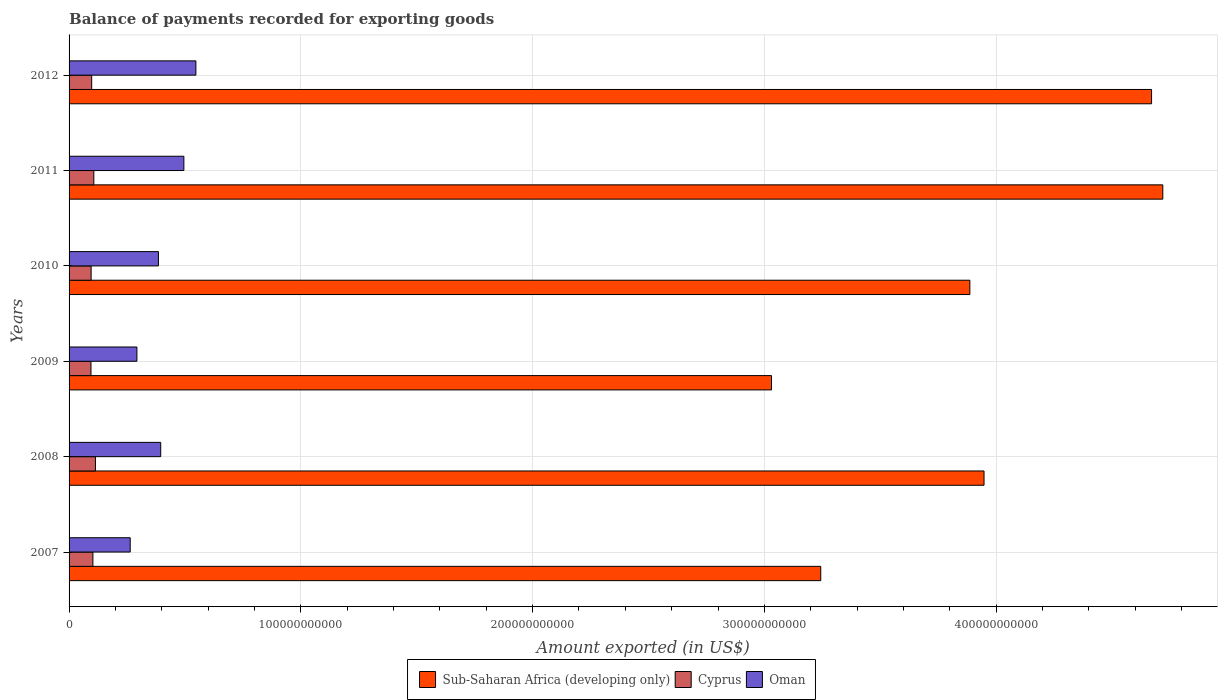How many different coloured bars are there?
Make the answer very short. 3. Are the number of bars per tick equal to the number of legend labels?
Your answer should be compact. Yes. Are the number of bars on each tick of the Y-axis equal?
Your answer should be very brief. Yes. How many bars are there on the 3rd tick from the top?
Make the answer very short. 3. What is the label of the 1st group of bars from the top?
Make the answer very short. 2012. What is the amount exported in Cyprus in 2010?
Your answer should be compact. 9.52e+09. Across all years, what is the maximum amount exported in Oman?
Ensure brevity in your answer.  5.47e+1. Across all years, what is the minimum amount exported in Sub-Saharan Africa (developing only)?
Make the answer very short. 3.03e+11. What is the total amount exported in Oman in the graph?
Your response must be concise. 2.38e+11. What is the difference between the amount exported in Sub-Saharan Africa (developing only) in 2007 and that in 2011?
Ensure brevity in your answer.  -1.48e+11. What is the difference between the amount exported in Sub-Saharan Africa (developing only) in 2011 and the amount exported in Oman in 2012?
Provide a short and direct response. 4.17e+11. What is the average amount exported in Cyprus per year?
Provide a short and direct response. 1.02e+1. In the year 2011, what is the difference between the amount exported in Cyprus and amount exported in Sub-Saharan Africa (developing only)?
Keep it short and to the point. -4.61e+11. In how many years, is the amount exported in Sub-Saharan Africa (developing only) greater than 40000000000 US$?
Your answer should be very brief. 6. What is the ratio of the amount exported in Sub-Saharan Africa (developing only) in 2008 to that in 2009?
Your answer should be compact. 1.3. Is the amount exported in Sub-Saharan Africa (developing only) in 2008 less than that in 2011?
Your answer should be compact. Yes. Is the difference between the amount exported in Cyprus in 2007 and 2011 greater than the difference between the amount exported in Sub-Saharan Africa (developing only) in 2007 and 2011?
Provide a succinct answer. Yes. What is the difference between the highest and the second highest amount exported in Sub-Saharan Africa (developing only)?
Ensure brevity in your answer.  4.85e+09. What is the difference between the highest and the lowest amount exported in Oman?
Give a very brief answer. 2.83e+1. In how many years, is the amount exported in Sub-Saharan Africa (developing only) greater than the average amount exported in Sub-Saharan Africa (developing only) taken over all years?
Provide a short and direct response. 3. Is the sum of the amount exported in Oman in 2008 and 2010 greater than the maximum amount exported in Sub-Saharan Africa (developing only) across all years?
Offer a terse response. No. What does the 2nd bar from the top in 2012 represents?
Your answer should be compact. Cyprus. What does the 3rd bar from the bottom in 2012 represents?
Your answer should be compact. Oman. Is it the case that in every year, the sum of the amount exported in Oman and amount exported in Sub-Saharan Africa (developing only) is greater than the amount exported in Cyprus?
Keep it short and to the point. Yes. How many bars are there?
Your response must be concise. 18. Are all the bars in the graph horizontal?
Make the answer very short. Yes. How many years are there in the graph?
Keep it short and to the point. 6. What is the difference between two consecutive major ticks on the X-axis?
Offer a terse response. 1.00e+11. Does the graph contain grids?
Make the answer very short. Yes. How are the legend labels stacked?
Make the answer very short. Horizontal. What is the title of the graph?
Ensure brevity in your answer.  Balance of payments recorded for exporting goods. What is the label or title of the X-axis?
Your answer should be compact. Amount exported (in US$). What is the Amount exported (in US$) of Sub-Saharan Africa (developing only) in 2007?
Ensure brevity in your answer.  3.24e+11. What is the Amount exported (in US$) of Cyprus in 2007?
Ensure brevity in your answer.  1.03e+1. What is the Amount exported (in US$) in Oman in 2007?
Give a very brief answer. 2.64e+1. What is the Amount exported (in US$) of Sub-Saharan Africa (developing only) in 2008?
Provide a short and direct response. 3.95e+11. What is the Amount exported (in US$) of Cyprus in 2008?
Your answer should be very brief. 1.14e+1. What is the Amount exported (in US$) of Oman in 2008?
Offer a very short reply. 3.95e+1. What is the Amount exported (in US$) of Sub-Saharan Africa (developing only) in 2009?
Keep it short and to the point. 3.03e+11. What is the Amount exported (in US$) of Cyprus in 2009?
Offer a very short reply. 9.46e+09. What is the Amount exported (in US$) in Oman in 2009?
Your answer should be very brief. 2.93e+1. What is the Amount exported (in US$) in Sub-Saharan Africa (developing only) in 2010?
Your answer should be compact. 3.89e+11. What is the Amount exported (in US$) in Cyprus in 2010?
Provide a short and direct response. 9.52e+09. What is the Amount exported (in US$) of Oman in 2010?
Your response must be concise. 3.86e+1. What is the Amount exported (in US$) of Sub-Saharan Africa (developing only) in 2011?
Your response must be concise. 4.72e+11. What is the Amount exported (in US$) of Cyprus in 2011?
Ensure brevity in your answer.  1.07e+1. What is the Amount exported (in US$) of Oman in 2011?
Your response must be concise. 4.95e+1. What is the Amount exported (in US$) in Sub-Saharan Africa (developing only) in 2012?
Your answer should be very brief. 4.67e+11. What is the Amount exported (in US$) in Cyprus in 2012?
Provide a succinct answer. 9.76e+09. What is the Amount exported (in US$) of Oman in 2012?
Ensure brevity in your answer.  5.47e+1. Across all years, what is the maximum Amount exported (in US$) of Sub-Saharan Africa (developing only)?
Offer a very short reply. 4.72e+11. Across all years, what is the maximum Amount exported (in US$) in Cyprus?
Offer a very short reply. 1.14e+1. Across all years, what is the maximum Amount exported (in US$) of Oman?
Offer a very short reply. 5.47e+1. Across all years, what is the minimum Amount exported (in US$) of Sub-Saharan Africa (developing only)?
Ensure brevity in your answer.  3.03e+11. Across all years, what is the minimum Amount exported (in US$) in Cyprus?
Offer a very short reply. 9.46e+09. Across all years, what is the minimum Amount exported (in US$) in Oman?
Give a very brief answer. 2.64e+1. What is the total Amount exported (in US$) in Sub-Saharan Africa (developing only) in the graph?
Provide a short and direct response. 2.35e+12. What is the total Amount exported (in US$) in Cyprus in the graph?
Make the answer very short. 6.11e+1. What is the total Amount exported (in US$) in Oman in the graph?
Offer a terse response. 2.38e+11. What is the difference between the Amount exported (in US$) in Sub-Saharan Africa (developing only) in 2007 and that in 2008?
Provide a short and direct response. -7.05e+1. What is the difference between the Amount exported (in US$) in Cyprus in 2007 and that in 2008?
Make the answer very short. -1.09e+09. What is the difference between the Amount exported (in US$) in Oman in 2007 and that in 2008?
Ensure brevity in your answer.  -1.32e+1. What is the difference between the Amount exported (in US$) in Sub-Saharan Africa (developing only) in 2007 and that in 2009?
Provide a short and direct response. 2.13e+1. What is the difference between the Amount exported (in US$) in Cyprus in 2007 and that in 2009?
Keep it short and to the point. 8.28e+08. What is the difference between the Amount exported (in US$) of Oman in 2007 and that in 2009?
Provide a succinct answer. -2.90e+09. What is the difference between the Amount exported (in US$) of Sub-Saharan Africa (developing only) in 2007 and that in 2010?
Provide a succinct answer. -6.43e+1. What is the difference between the Amount exported (in US$) of Cyprus in 2007 and that in 2010?
Provide a succinct answer. 7.69e+08. What is the difference between the Amount exported (in US$) of Oman in 2007 and that in 2010?
Give a very brief answer. -1.22e+1. What is the difference between the Amount exported (in US$) in Sub-Saharan Africa (developing only) in 2007 and that in 2011?
Offer a terse response. -1.48e+11. What is the difference between the Amount exported (in US$) in Cyprus in 2007 and that in 2011?
Give a very brief answer. -3.96e+08. What is the difference between the Amount exported (in US$) of Oman in 2007 and that in 2011?
Your response must be concise. -2.32e+1. What is the difference between the Amount exported (in US$) of Sub-Saharan Africa (developing only) in 2007 and that in 2012?
Your response must be concise. -1.43e+11. What is the difference between the Amount exported (in US$) of Cyprus in 2007 and that in 2012?
Ensure brevity in your answer.  5.29e+08. What is the difference between the Amount exported (in US$) of Oman in 2007 and that in 2012?
Your answer should be compact. -2.83e+1. What is the difference between the Amount exported (in US$) of Sub-Saharan Africa (developing only) in 2008 and that in 2009?
Give a very brief answer. 9.17e+1. What is the difference between the Amount exported (in US$) of Cyprus in 2008 and that in 2009?
Offer a very short reply. 1.92e+09. What is the difference between the Amount exported (in US$) of Oman in 2008 and that in 2009?
Your response must be concise. 1.03e+1. What is the difference between the Amount exported (in US$) in Sub-Saharan Africa (developing only) in 2008 and that in 2010?
Ensure brevity in your answer.  6.12e+09. What is the difference between the Amount exported (in US$) of Cyprus in 2008 and that in 2010?
Your response must be concise. 1.86e+09. What is the difference between the Amount exported (in US$) in Oman in 2008 and that in 2010?
Your answer should be very brief. 9.86e+08. What is the difference between the Amount exported (in US$) of Sub-Saharan Africa (developing only) in 2008 and that in 2011?
Provide a short and direct response. -7.71e+1. What is the difference between the Amount exported (in US$) in Cyprus in 2008 and that in 2011?
Your answer should be compact. 6.98e+08. What is the difference between the Amount exported (in US$) of Oman in 2008 and that in 2011?
Make the answer very short. -9.99e+09. What is the difference between the Amount exported (in US$) in Sub-Saharan Africa (developing only) in 2008 and that in 2012?
Offer a terse response. -7.23e+1. What is the difference between the Amount exported (in US$) of Cyprus in 2008 and that in 2012?
Offer a very short reply. 1.62e+09. What is the difference between the Amount exported (in US$) of Oman in 2008 and that in 2012?
Ensure brevity in your answer.  -1.52e+1. What is the difference between the Amount exported (in US$) in Sub-Saharan Africa (developing only) in 2009 and that in 2010?
Give a very brief answer. -8.56e+1. What is the difference between the Amount exported (in US$) of Cyprus in 2009 and that in 2010?
Give a very brief answer. -5.90e+07. What is the difference between the Amount exported (in US$) of Oman in 2009 and that in 2010?
Ensure brevity in your answer.  -9.29e+09. What is the difference between the Amount exported (in US$) in Sub-Saharan Africa (developing only) in 2009 and that in 2011?
Make the answer very short. -1.69e+11. What is the difference between the Amount exported (in US$) of Cyprus in 2009 and that in 2011?
Provide a short and direct response. -1.22e+09. What is the difference between the Amount exported (in US$) in Oman in 2009 and that in 2011?
Your answer should be very brief. -2.03e+1. What is the difference between the Amount exported (in US$) in Sub-Saharan Africa (developing only) in 2009 and that in 2012?
Provide a succinct answer. -1.64e+11. What is the difference between the Amount exported (in US$) of Cyprus in 2009 and that in 2012?
Ensure brevity in your answer.  -2.98e+08. What is the difference between the Amount exported (in US$) in Oman in 2009 and that in 2012?
Your answer should be compact. -2.55e+1. What is the difference between the Amount exported (in US$) in Sub-Saharan Africa (developing only) in 2010 and that in 2011?
Provide a short and direct response. -8.33e+1. What is the difference between the Amount exported (in US$) of Cyprus in 2010 and that in 2011?
Provide a short and direct response. -1.16e+09. What is the difference between the Amount exported (in US$) of Oman in 2010 and that in 2011?
Your response must be concise. -1.10e+1. What is the difference between the Amount exported (in US$) of Sub-Saharan Africa (developing only) in 2010 and that in 2012?
Make the answer very short. -7.84e+1. What is the difference between the Amount exported (in US$) in Cyprus in 2010 and that in 2012?
Your answer should be compact. -2.39e+08. What is the difference between the Amount exported (in US$) of Oman in 2010 and that in 2012?
Give a very brief answer. -1.62e+1. What is the difference between the Amount exported (in US$) in Sub-Saharan Africa (developing only) in 2011 and that in 2012?
Your answer should be very brief. 4.85e+09. What is the difference between the Amount exported (in US$) in Cyprus in 2011 and that in 2012?
Provide a short and direct response. 9.25e+08. What is the difference between the Amount exported (in US$) in Oman in 2011 and that in 2012?
Offer a terse response. -5.19e+09. What is the difference between the Amount exported (in US$) in Sub-Saharan Africa (developing only) in 2007 and the Amount exported (in US$) in Cyprus in 2008?
Provide a short and direct response. 3.13e+11. What is the difference between the Amount exported (in US$) in Sub-Saharan Africa (developing only) in 2007 and the Amount exported (in US$) in Oman in 2008?
Give a very brief answer. 2.85e+11. What is the difference between the Amount exported (in US$) of Cyprus in 2007 and the Amount exported (in US$) of Oman in 2008?
Ensure brevity in your answer.  -2.93e+1. What is the difference between the Amount exported (in US$) of Sub-Saharan Africa (developing only) in 2007 and the Amount exported (in US$) of Cyprus in 2009?
Provide a short and direct response. 3.15e+11. What is the difference between the Amount exported (in US$) of Sub-Saharan Africa (developing only) in 2007 and the Amount exported (in US$) of Oman in 2009?
Your answer should be compact. 2.95e+11. What is the difference between the Amount exported (in US$) in Cyprus in 2007 and the Amount exported (in US$) in Oman in 2009?
Your answer should be compact. -1.90e+1. What is the difference between the Amount exported (in US$) in Sub-Saharan Africa (developing only) in 2007 and the Amount exported (in US$) in Cyprus in 2010?
Your answer should be compact. 3.15e+11. What is the difference between the Amount exported (in US$) in Sub-Saharan Africa (developing only) in 2007 and the Amount exported (in US$) in Oman in 2010?
Your answer should be very brief. 2.86e+11. What is the difference between the Amount exported (in US$) in Cyprus in 2007 and the Amount exported (in US$) in Oman in 2010?
Your response must be concise. -2.83e+1. What is the difference between the Amount exported (in US$) of Sub-Saharan Africa (developing only) in 2007 and the Amount exported (in US$) of Cyprus in 2011?
Offer a very short reply. 3.14e+11. What is the difference between the Amount exported (in US$) of Sub-Saharan Africa (developing only) in 2007 and the Amount exported (in US$) of Oman in 2011?
Provide a succinct answer. 2.75e+11. What is the difference between the Amount exported (in US$) in Cyprus in 2007 and the Amount exported (in US$) in Oman in 2011?
Your answer should be very brief. -3.92e+1. What is the difference between the Amount exported (in US$) in Sub-Saharan Africa (developing only) in 2007 and the Amount exported (in US$) in Cyprus in 2012?
Provide a succinct answer. 3.15e+11. What is the difference between the Amount exported (in US$) of Sub-Saharan Africa (developing only) in 2007 and the Amount exported (in US$) of Oman in 2012?
Your response must be concise. 2.70e+11. What is the difference between the Amount exported (in US$) in Cyprus in 2007 and the Amount exported (in US$) in Oman in 2012?
Provide a succinct answer. -4.44e+1. What is the difference between the Amount exported (in US$) of Sub-Saharan Africa (developing only) in 2008 and the Amount exported (in US$) of Cyprus in 2009?
Keep it short and to the point. 3.85e+11. What is the difference between the Amount exported (in US$) of Sub-Saharan Africa (developing only) in 2008 and the Amount exported (in US$) of Oman in 2009?
Give a very brief answer. 3.66e+11. What is the difference between the Amount exported (in US$) in Cyprus in 2008 and the Amount exported (in US$) in Oman in 2009?
Your response must be concise. -1.79e+1. What is the difference between the Amount exported (in US$) in Sub-Saharan Africa (developing only) in 2008 and the Amount exported (in US$) in Cyprus in 2010?
Offer a terse response. 3.85e+11. What is the difference between the Amount exported (in US$) in Sub-Saharan Africa (developing only) in 2008 and the Amount exported (in US$) in Oman in 2010?
Your response must be concise. 3.56e+11. What is the difference between the Amount exported (in US$) in Cyprus in 2008 and the Amount exported (in US$) in Oman in 2010?
Your answer should be very brief. -2.72e+1. What is the difference between the Amount exported (in US$) of Sub-Saharan Africa (developing only) in 2008 and the Amount exported (in US$) of Cyprus in 2011?
Your answer should be compact. 3.84e+11. What is the difference between the Amount exported (in US$) of Sub-Saharan Africa (developing only) in 2008 and the Amount exported (in US$) of Oman in 2011?
Give a very brief answer. 3.45e+11. What is the difference between the Amount exported (in US$) in Cyprus in 2008 and the Amount exported (in US$) in Oman in 2011?
Your answer should be compact. -3.82e+1. What is the difference between the Amount exported (in US$) in Sub-Saharan Africa (developing only) in 2008 and the Amount exported (in US$) in Cyprus in 2012?
Make the answer very short. 3.85e+11. What is the difference between the Amount exported (in US$) in Sub-Saharan Africa (developing only) in 2008 and the Amount exported (in US$) in Oman in 2012?
Keep it short and to the point. 3.40e+11. What is the difference between the Amount exported (in US$) of Cyprus in 2008 and the Amount exported (in US$) of Oman in 2012?
Provide a short and direct response. -4.33e+1. What is the difference between the Amount exported (in US$) of Sub-Saharan Africa (developing only) in 2009 and the Amount exported (in US$) of Cyprus in 2010?
Make the answer very short. 2.94e+11. What is the difference between the Amount exported (in US$) in Sub-Saharan Africa (developing only) in 2009 and the Amount exported (in US$) in Oman in 2010?
Your response must be concise. 2.65e+11. What is the difference between the Amount exported (in US$) of Cyprus in 2009 and the Amount exported (in US$) of Oman in 2010?
Provide a succinct answer. -2.91e+1. What is the difference between the Amount exported (in US$) of Sub-Saharan Africa (developing only) in 2009 and the Amount exported (in US$) of Cyprus in 2011?
Your answer should be compact. 2.92e+11. What is the difference between the Amount exported (in US$) of Sub-Saharan Africa (developing only) in 2009 and the Amount exported (in US$) of Oman in 2011?
Offer a very short reply. 2.54e+11. What is the difference between the Amount exported (in US$) of Cyprus in 2009 and the Amount exported (in US$) of Oman in 2011?
Your answer should be very brief. -4.01e+1. What is the difference between the Amount exported (in US$) of Sub-Saharan Africa (developing only) in 2009 and the Amount exported (in US$) of Cyprus in 2012?
Give a very brief answer. 2.93e+11. What is the difference between the Amount exported (in US$) in Sub-Saharan Africa (developing only) in 2009 and the Amount exported (in US$) in Oman in 2012?
Keep it short and to the point. 2.48e+11. What is the difference between the Amount exported (in US$) of Cyprus in 2009 and the Amount exported (in US$) of Oman in 2012?
Your response must be concise. -4.53e+1. What is the difference between the Amount exported (in US$) in Sub-Saharan Africa (developing only) in 2010 and the Amount exported (in US$) in Cyprus in 2011?
Offer a very short reply. 3.78e+11. What is the difference between the Amount exported (in US$) of Sub-Saharan Africa (developing only) in 2010 and the Amount exported (in US$) of Oman in 2011?
Your response must be concise. 3.39e+11. What is the difference between the Amount exported (in US$) in Cyprus in 2010 and the Amount exported (in US$) in Oman in 2011?
Offer a very short reply. -4.00e+1. What is the difference between the Amount exported (in US$) in Sub-Saharan Africa (developing only) in 2010 and the Amount exported (in US$) in Cyprus in 2012?
Make the answer very short. 3.79e+11. What is the difference between the Amount exported (in US$) in Sub-Saharan Africa (developing only) in 2010 and the Amount exported (in US$) in Oman in 2012?
Make the answer very short. 3.34e+11. What is the difference between the Amount exported (in US$) in Cyprus in 2010 and the Amount exported (in US$) in Oman in 2012?
Offer a very short reply. -4.52e+1. What is the difference between the Amount exported (in US$) of Sub-Saharan Africa (developing only) in 2011 and the Amount exported (in US$) of Cyprus in 2012?
Provide a short and direct response. 4.62e+11. What is the difference between the Amount exported (in US$) of Sub-Saharan Africa (developing only) in 2011 and the Amount exported (in US$) of Oman in 2012?
Provide a short and direct response. 4.17e+11. What is the difference between the Amount exported (in US$) of Cyprus in 2011 and the Amount exported (in US$) of Oman in 2012?
Offer a very short reply. -4.40e+1. What is the average Amount exported (in US$) of Sub-Saharan Africa (developing only) per year?
Your answer should be compact. 3.92e+11. What is the average Amount exported (in US$) in Cyprus per year?
Your answer should be compact. 1.02e+1. What is the average Amount exported (in US$) of Oman per year?
Give a very brief answer. 3.97e+1. In the year 2007, what is the difference between the Amount exported (in US$) of Sub-Saharan Africa (developing only) and Amount exported (in US$) of Cyprus?
Provide a succinct answer. 3.14e+11. In the year 2007, what is the difference between the Amount exported (in US$) in Sub-Saharan Africa (developing only) and Amount exported (in US$) in Oman?
Make the answer very short. 2.98e+11. In the year 2007, what is the difference between the Amount exported (in US$) in Cyprus and Amount exported (in US$) in Oman?
Your answer should be very brief. -1.61e+1. In the year 2008, what is the difference between the Amount exported (in US$) of Sub-Saharan Africa (developing only) and Amount exported (in US$) of Cyprus?
Give a very brief answer. 3.83e+11. In the year 2008, what is the difference between the Amount exported (in US$) of Sub-Saharan Africa (developing only) and Amount exported (in US$) of Oman?
Your answer should be very brief. 3.55e+11. In the year 2008, what is the difference between the Amount exported (in US$) in Cyprus and Amount exported (in US$) in Oman?
Offer a terse response. -2.82e+1. In the year 2009, what is the difference between the Amount exported (in US$) in Sub-Saharan Africa (developing only) and Amount exported (in US$) in Cyprus?
Ensure brevity in your answer.  2.94e+11. In the year 2009, what is the difference between the Amount exported (in US$) in Sub-Saharan Africa (developing only) and Amount exported (in US$) in Oman?
Give a very brief answer. 2.74e+11. In the year 2009, what is the difference between the Amount exported (in US$) of Cyprus and Amount exported (in US$) of Oman?
Give a very brief answer. -1.98e+1. In the year 2010, what is the difference between the Amount exported (in US$) of Sub-Saharan Africa (developing only) and Amount exported (in US$) of Cyprus?
Offer a very short reply. 3.79e+11. In the year 2010, what is the difference between the Amount exported (in US$) of Sub-Saharan Africa (developing only) and Amount exported (in US$) of Oman?
Ensure brevity in your answer.  3.50e+11. In the year 2010, what is the difference between the Amount exported (in US$) of Cyprus and Amount exported (in US$) of Oman?
Provide a succinct answer. -2.90e+1. In the year 2011, what is the difference between the Amount exported (in US$) in Sub-Saharan Africa (developing only) and Amount exported (in US$) in Cyprus?
Provide a succinct answer. 4.61e+11. In the year 2011, what is the difference between the Amount exported (in US$) in Sub-Saharan Africa (developing only) and Amount exported (in US$) in Oman?
Your answer should be compact. 4.22e+11. In the year 2011, what is the difference between the Amount exported (in US$) of Cyprus and Amount exported (in US$) of Oman?
Ensure brevity in your answer.  -3.89e+1. In the year 2012, what is the difference between the Amount exported (in US$) in Sub-Saharan Africa (developing only) and Amount exported (in US$) in Cyprus?
Your answer should be compact. 4.57e+11. In the year 2012, what is the difference between the Amount exported (in US$) of Sub-Saharan Africa (developing only) and Amount exported (in US$) of Oman?
Offer a very short reply. 4.12e+11. In the year 2012, what is the difference between the Amount exported (in US$) in Cyprus and Amount exported (in US$) in Oman?
Give a very brief answer. -4.50e+1. What is the ratio of the Amount exported (in US$) of Sub-Saharan Africa (developing only) in 2007 to that in 2008?
Provide a succinct answer. 0.82. What is the ratio of the Amount exported (in US$) of Cyprus in 2007 to that in 2008?
Make the answer very short. 0.9. What is the ratio of the Amount exported (in US$) in Oman in 2007 to that in 2008?
Your answer should be very brief. 0.67. What is the ratio of the Amount exported (in US$) of Sub-Saharan Africa (developing only) in 2007 to that in 2009?
Offer a very short reply. 1.07. What is the ratio of the Amount exported (in US$) of Cyprus in 2007 to that in 2009?
Provide a short and direct response. 1.09. What is the ratio of the Amount exported (in US$) in Oman in 2007 to that in 2009?
Keep it short and to the point. 0.9. What is the ratio of the Amount exported (in US$) of Sub-Saharan Africa (developing only) in 2007 to that in 2010?
Make the answer very short. 0.83. What is the ratio of the Amount exported (in US$) of Cyprus in 2007 to that in 2010?
Provide a succinct answer. 1.08. What is the ratio of the Amount exported (in US$) in Oman in 2007 to that in 2010?
Keep it short and to the point. 0.68. What is the ratio of the Amount exported (in US$) of Sub-Saharan Africa (developing only) in 2007 to that in 2011?
Offer a very short reply. 0.69. What is the ratio of the Amount exported (in US$) in Cyprus in 2007 to that in 2011?
Offer a very short reply. 0.96. What is the ratio of the Amount exported (in US$) of Oman in 2007 to that in 2011?
Provide a succinct answer. 0.53. What is the ratio of the Amount exported (in US$) in Sub-Saharan Africa (developing only) in 2007 to that in 2012?
Your response must be concise. 0.69. What is the ratio of the Amount exported (in US$) of Cyprus in 2007 to that in 2012?
Make the answer very short. 1.05. What is the ratio of the Amount exported (in US$) in Oman in 2007 to that in 2012?
Provide a short and direct response. 0.48. What is the ratio of the Amount exported (in US$) in Sub-Saharan Africa (developing only) in 2008 to that in 2009?
Make the answer very short. 1.3. What is the ratio of the Amount exported (in US$) of Cyprus in 2008 to that in 2009?
Your answer should be compact. 1.2. What is the ratio of the Amount exported (in US$) of Oman in 2008 to that in 2009?
Ensure brevity in your answer.  1.35. What is the ratio of the Amount exported (in US$) of Sub-Saharan Africa (developing only) in 2008 to that in 2010?
Your answer should be very brief. 1.02. What is the ratio of the Amount exported (in US$) of Cyprus in 2008 to that in 2010?
Offer a very short reply. 1.2. What is the ratio of the Amount exported (in US$) of Oman in 2008 to that in 2010?
Keep it short and to the point. 1.03. What is the ratio of the Amount exported (in US$) in Sub-Saharan Africa (developing only) in 2008 to that in 2011?
Give a very brief answer. 0.84. What is the ratio of the Amount exported (in US$) of Cyprus in 2008 to that in 2011?
Your response must be concise. 1.07. What is the ratio of the Amount exported (in US$) of Oman in 2008 to that in 2011?
Offer a very short reply. 0.8. What is the ratio of the Amount exported (in US$) in Sub-Saharan Africa (developing only) in 2008 to that in 2012?
Offer a terse response. 0.85. What is the ratio of the Amount exported (in US$) in Cyprus in 2008 to that in 2012?
Make the answer very short. 1.17. What is the ratio of the Amount exported (in US$) in Oman in 2008 to that in 2012?
Ensure brevity in your answer.  0.72. What is the ratio of the Amount exported (in US$) in Sub-Saharan Africa (developing only) in 2009 to that in 2010?
Make the answer very short. 0.78. What is the ratio of the Amount exported (in US$) of Oman in 2009 to that in 2010?
Provide a succinct answer. 0.76. What is the ratio of the Amount exported (in US$) in Sub-Saharan Africa (developing only) in 2009 to that in 2011?
Your response must be concise. 0.64. What is the ratio of the Amount exported (in US$) in Cyprus in 2009 to that in 2011?
Offer a very short reply. 0.89. What is the ratio of the Amount exported (in US$) in Oman in 2009 to that in 2011?
Keep it short and to the point. 0.59. What is the ratio of the Amount exported (in US$) in Sub-Saharan Africa (developing only) in 2009 to that in 2012?
Offer a very short reply. 0.65. What is the ratio of the Amount exported (in US$) of Cyprus in 2009 to that in 2012?
Make the answer very short. 0.97. What is the ratio of the Amount exported (in US$) of Oman in 2009 to that in 2012?
Make the answer very short. 0.53. What is the ratio of the Amount exported (in US$) of Sub-Saharan Africa (developing only) in 2010 to that in 2011?
Give a very brief answer. 0.82. What is the ratio of the Amount exported (in US$) in Cyprus in 2010 to that in 2011?
Give a very brief answer. 0.89. What is the ratio of the Amount exported (in US$) of Oman in 2010 to that in 2011?
Offer a terse response. 0.78. What is the ratio of the Amount exported (in US$) of Sub-Saharan Africa (developing only) in 2010 to that in 2012?
Give a very brief answer. 0.83. What is the ratio of the Amount exported (in US$) of Cyprus in 2010 to that in 2012?
Give a very brief answer. 0.98. What is the ratio of the Amount exported (in US$) in Oman in 2010 to that in 2012?
Provide a short and direct response. 0.7. What is the ratio of the Amount exported (in US$) of Sub-Saharan Africa (developing only) in 2011 to that in 2012?
Provide a succinct answer. 1.01. What is the ratio of the Amount exported (in US$) of Cyprus in 2011 to that in 2012?
Ensure brevity in your answer.  1.09. What is the ratio of the Amount exported (in US$) of Oman in 2011 to that in 2012?
Provide a succinct answer. 0.91. What is the difference between the highest and the second highest Amount exported (in US$) in Sub-Saharan Africa (developing only)?
Ensure brevity in your answer.  4.85e+09. What is the difference between the highest and the second highest Amount exported (in US$) of Cyprus?
Your answer should be compact. 6.98e+08. What is the difference between the highest and the second highest Amount exported (in US$) of Oman?
Offer a terse response. 5.19e+09. What is the difference between the highest and the lowest Amount exported (in US$) of Sub-Saharan Africa (developing only)?
Your answer should be compact. 1.69e+11. What is the difference between the highest and the lowest Amount exported (in US$) in Cyprus?
Your response must be concise. 1.92e+09. What is the difference between the highest and the lowest Amount exported (in US$) in Oman?
Keep it short and to the point. 2.83e+1. 